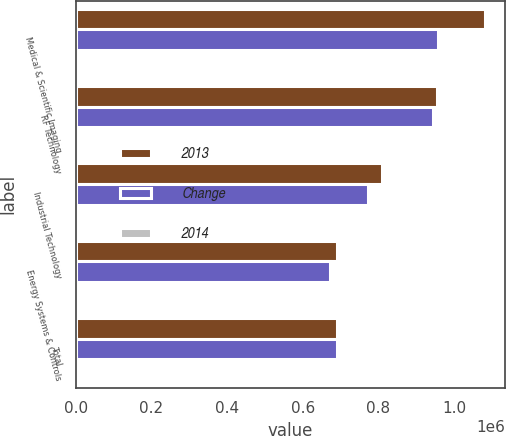Convert chart. <chart><loc_0><loc_0><loc_500><loc_500><stacked_bar_chart><ecel><fcel>Medical & Scientific Imaging<fcel>RF Technology<fcel>Industrial Technology<fcel>Energy Systems & Controls<fcel>Total<nl><fcel>2013<fcel>1.08119e+06<fcel>955831<fcel>808921<fcel>692136<fcel>692136<nl><fcel>Change<fcel>958830<fcel>943757<fcel>772337<fcel>673569<fcel>692136<nl><fcel>2014<fcel>12.8<fcel>1.3<fcel>4.7<fcel>2.8<fcel>5.7<nl></chart> 